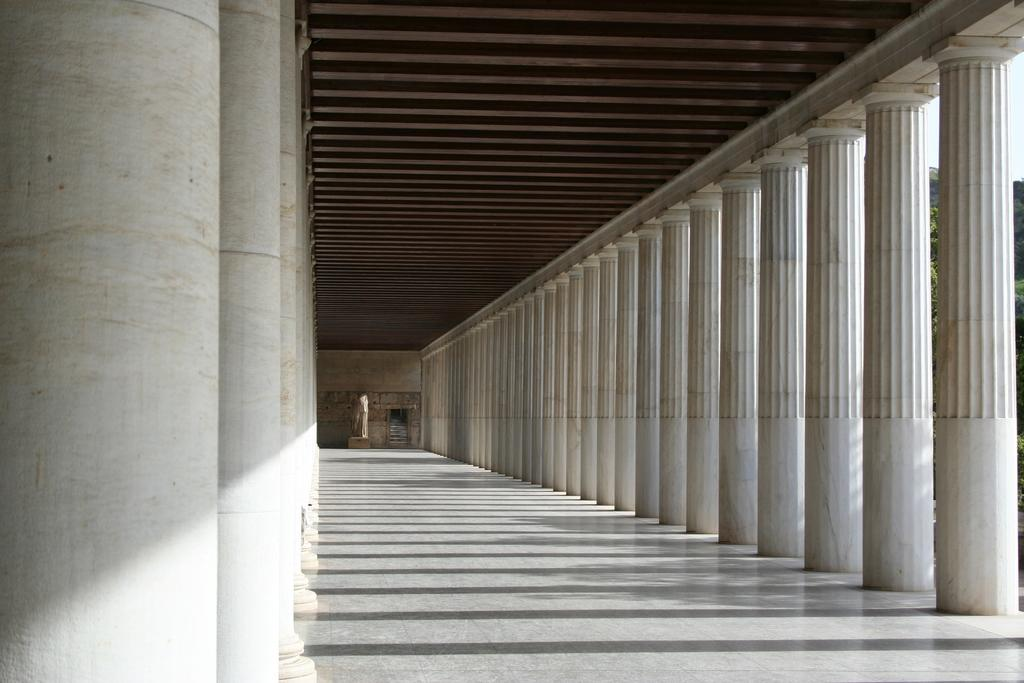What type of architectural feature can be seen in the image? There is a corridor in the image. What structural elements are present in the corridor? There are pillars in the image. What type of natural elements are visible in the image? There are trees in the image. What is visible in the background of the image? The sky is visible in the image. How many cakes are stacked on top of each other in the image? There are no cakes present in the image. What type of tomatoes can be seen growing on the trees in the image? There are no tomatoes or trees growing tomatoes in the image. 